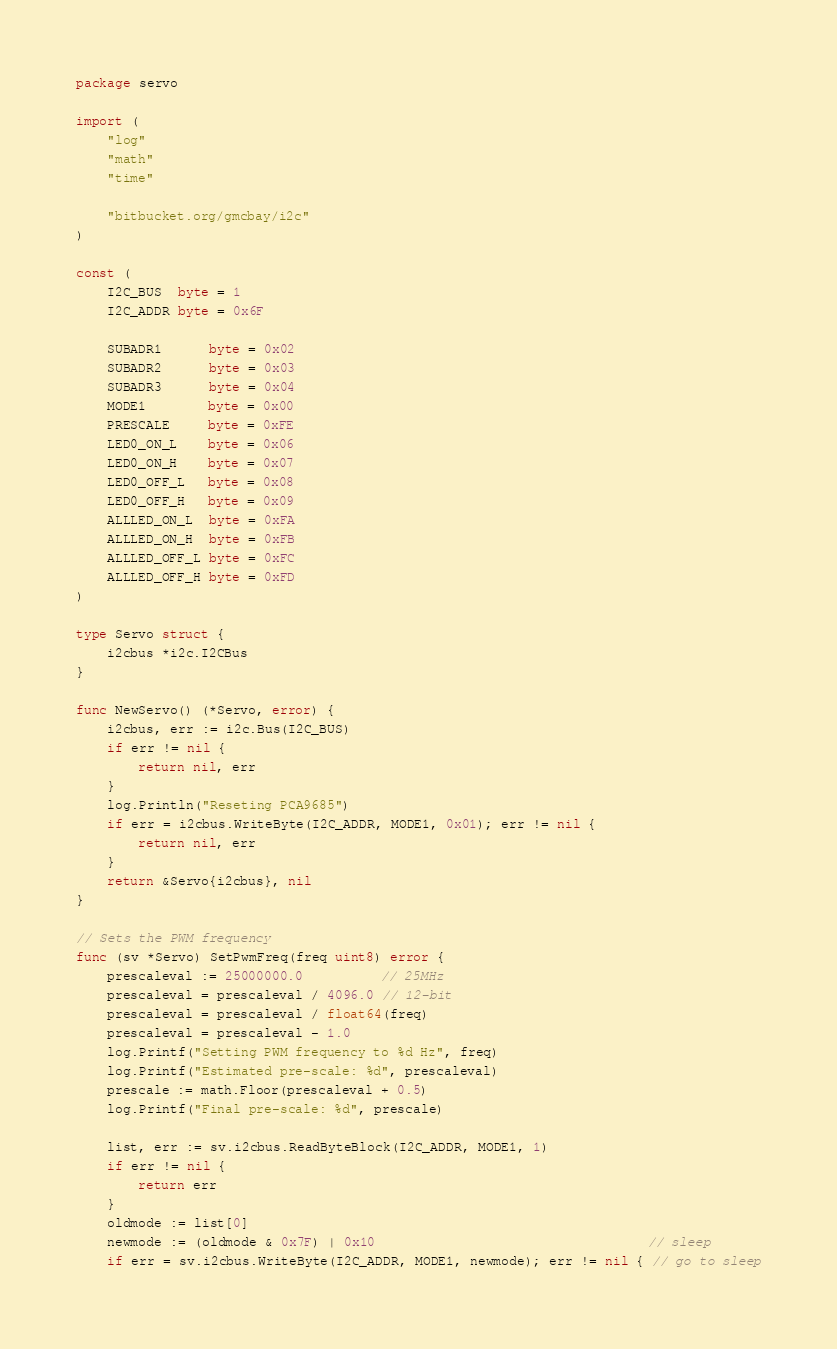Convert code to text. <code><loc_0><loc_0><loc_500><loc_500><_Go_>package servo

import (
	"log"
	"math"
	"time"

	"bitbucket.org/gmcbay/i2c"
)

const (
	I2C_BUS  byte = 1
	I2C_ADDR byte = 0x6F

	SUBADR1      byte = 0x02
	SUBADR2      byte = 0x03
	SUBADR3      byte = 0x04
	MODE1        byte = 0x00
	PRESCALE     byte = 0xFE
	LED0_ON_L    byte = 0x06
	LED0_ON_H    byte = 0x07
	LED0_OFF_L   byte = 0x08
	LED0_OFF_H   byte = 0x09
	ALLLED_ON_L  byte = 0xFA
	ALLLED_ON_H  byte = 0xFB
	ALLLED_OFF_L byte = 0xFC
	ALLLED_OFF_H byte = 0xFD
)

type Servo struct {
	i2cbus *i2c.I2CBus
}

func NewServo() (*Servo, error) {
	i2cbus, err := i2c.Bus(I2C_BUS)
	if err != nil {
		return nil, err
	}
	log.Println("Reseting PCA9685")
	if err = i2cbus.WriteByte(I2C_ADDR, MODE1, 0x01); err != nil {
		return nil, err
	}
	return &Servo{i2cbus}, nil
}

// Sets the PWM frequency
func (sv *Servo) SetPwmFreq(freq uint8) error {
	prescaleval := 25000000.0          // 25MHz
	prescaleval = prescaleval / 4096.0 // 12-bit
	prescaleval = prescaleval / float64(freq)
	prescaleval = prescaleval - 1.0
	log.Printf("Setting PWM frequency to %d Hz", freq)
	log.Printf("Estimated pre-scale: %d", prescaleval)
	prescale := math.Floor(prescaleval + 0.5)
	log.Printf("Final pre-scale: %d", prescale)

	list, err := sv.i2cbus.ReadByteBlock(I2C_ADDR, MODE1, 1)
	if err != nil {
		return err
	}
	oldmode := list[0]
	newmode := (oldmode & 0x7F) | 0x10                                   // sleep
	if err = sv.i2cbus.WriteByte(I2C_ADDR, MODE1, newmode); err != nil { // go to sleep</code> 